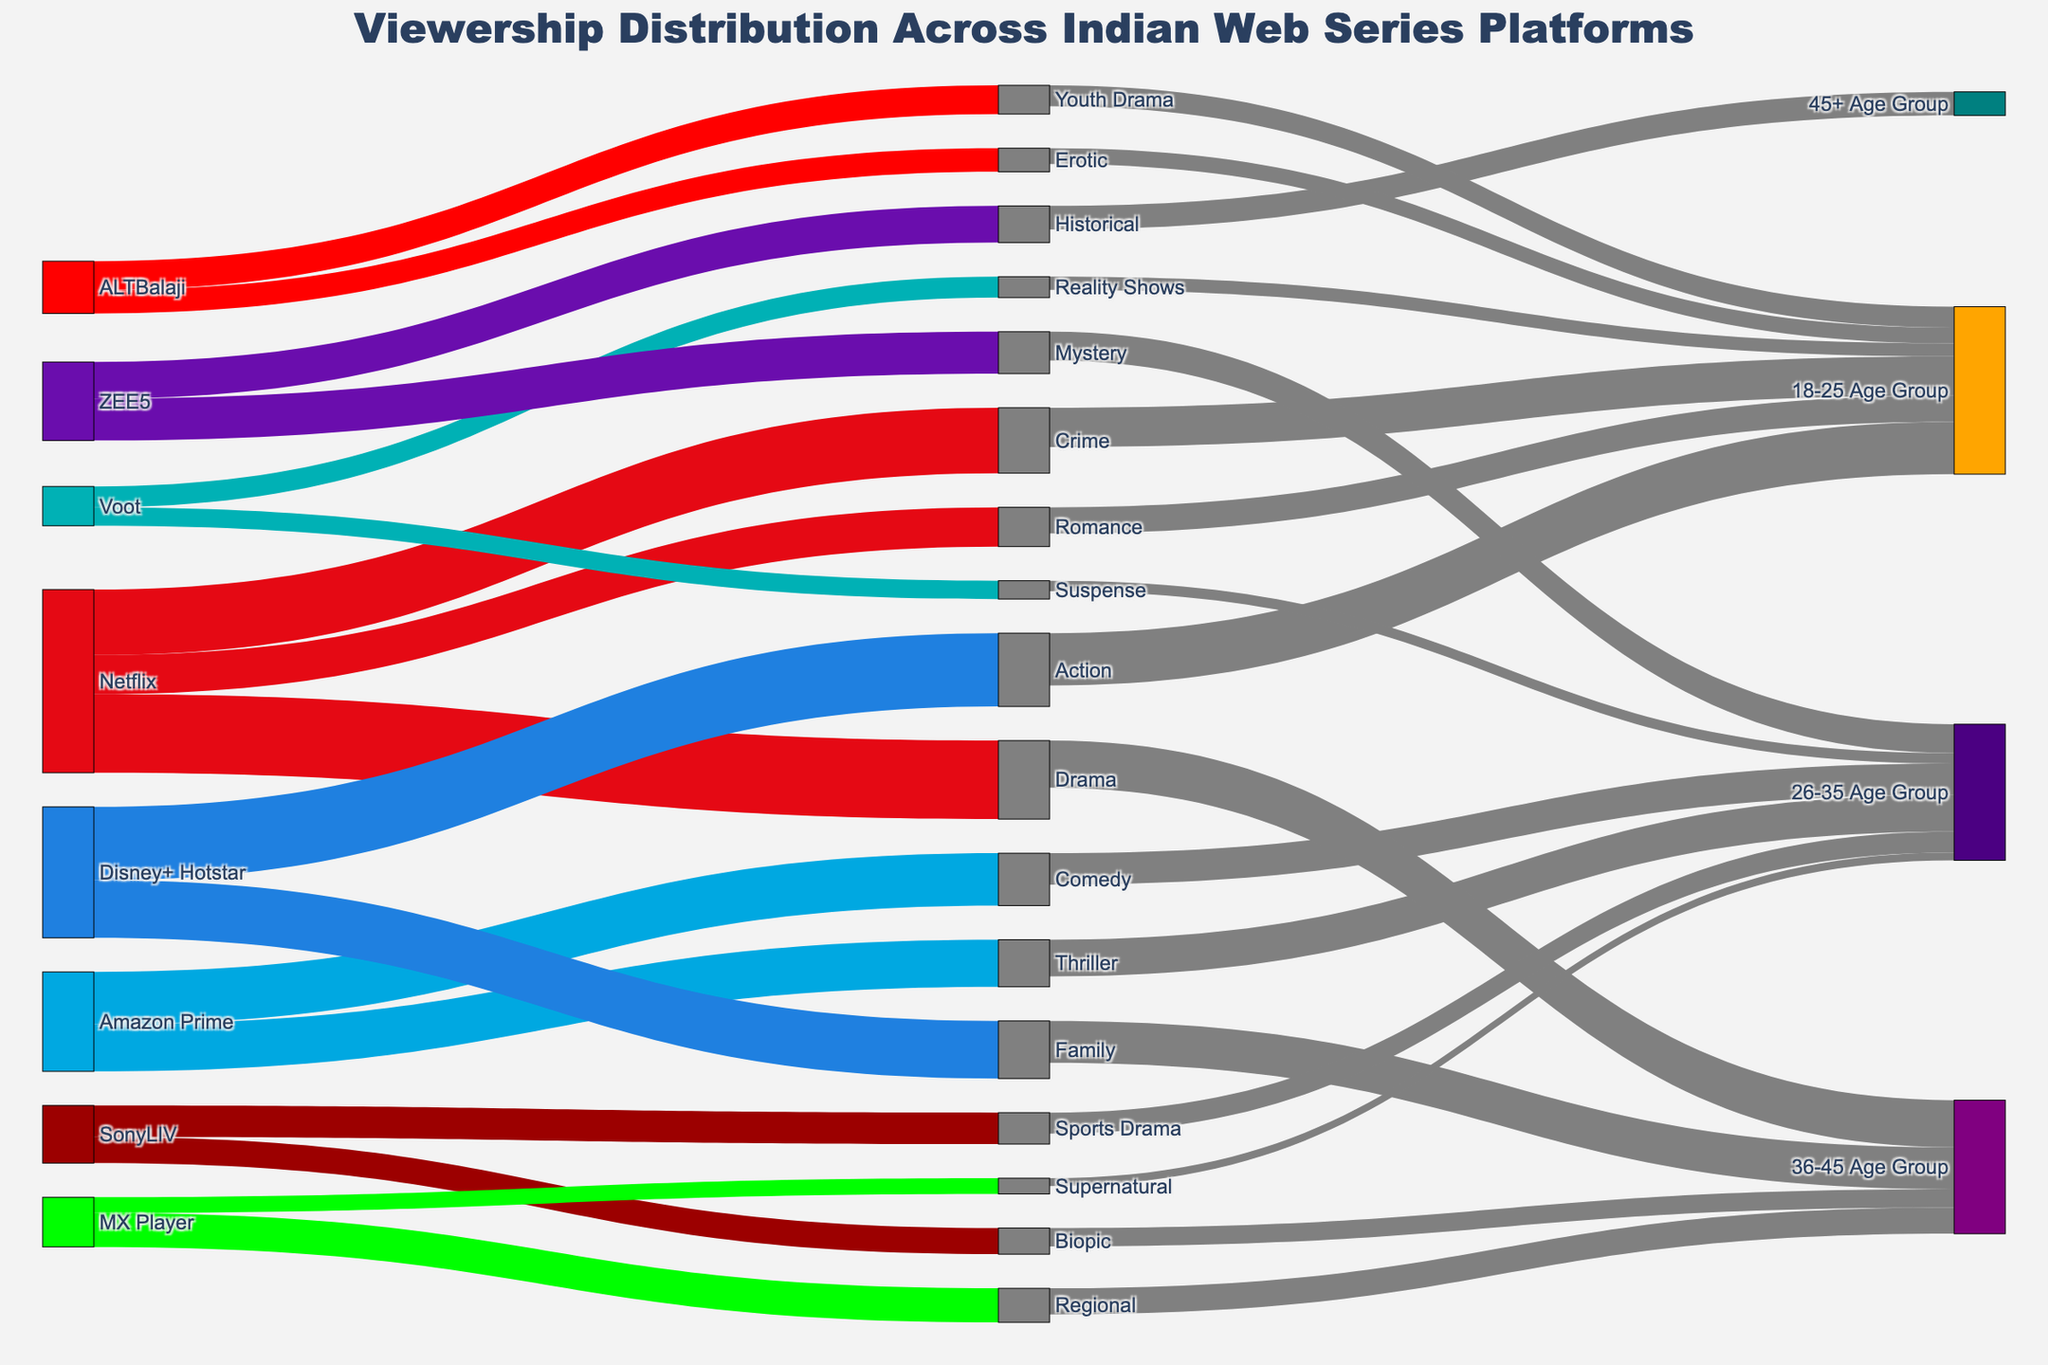What's the title of this Sankey Diagram? The title of a Sankey Diagram is typically located at the top of the figure. By looking at this specific diagram, we can see the title clearly written as "Viewership Distribution Across Indian Web Series Platforms".
Answer: Viewership Distribution Across Indian Web Series Platforms Which platform has the highest viewership for Drama series? By tracing the node labeled "Drama" back to its source, we observe that "Netflix" is the platform providing the highest viewership for Drama series at 30 units.
Answer: Netflix Which genre on Amazon Prime has the lowest viewership? Look at the genres connected to Amazon Prime. The genre with the smallest value connected to Amazon Prime is "Thriller" with 18 units.
Answer: Thriller What is the combined viewership for the genres connected to Disney+ Hotstar? Add the viewership values for the genres connected to Disney+ Hotstar: Family (22) and Action (28). So, 22 + 28 = 50.
Answer: 50 Of all genres, which one captures the attention of the 18-25 age group the most? Identify the genres that direct their flow towards "18-25 Age Group" and compare their viewership values: Crime (15), Romance (10), Action (20), Reality Shows (5), Erotic (6), and Youth Drama (8). Action has the highest viewership at 20 units.
Answer: Action Compare the total viewership for Crime and Romance combined versus Comedy and Thriller combined. Which is higher? Add the viewership for Crime (25) and Romance (15) which equals 40. Add Comedy (20) and Thriller (18) which equals 38. Therefore, Crime and Romance combined have a higher viewership at 40 units.
Answer: Crime and Romance combined Which age group is the primary audience for Biopics? By following the flow from "Biopic", you can see that it leads to "36-45 Age Group" with 7 units.
Answer: 36-45 Age Group How many platforms have genres exclusively connecting to the 18-25 age group? Check each platform and count how many have connections only leading to the "18-25 Age Group". The platforms with genres exclusively connecting to the 18-25 age group are ALTBalaji (Erotic, Youth Drama) and Reality Shows, Suspense, both on Voot and MX Player. Count these as one each for ALTBalaji and Voot. Total is 2.
Answer: 2 Which platform has the most diverse set of genres in terms of viewership? Count the number of unique genres each platform is connected to: Netflix (3), Amazon Prime (2), Disney+ Hotstar (2), SonyLIV (2), Voot (2), ZEE5 (2), ALTBalaji (2), and MX Player (2). Netflix has the highest number of unique genres at 3.
Answer: Netflix 